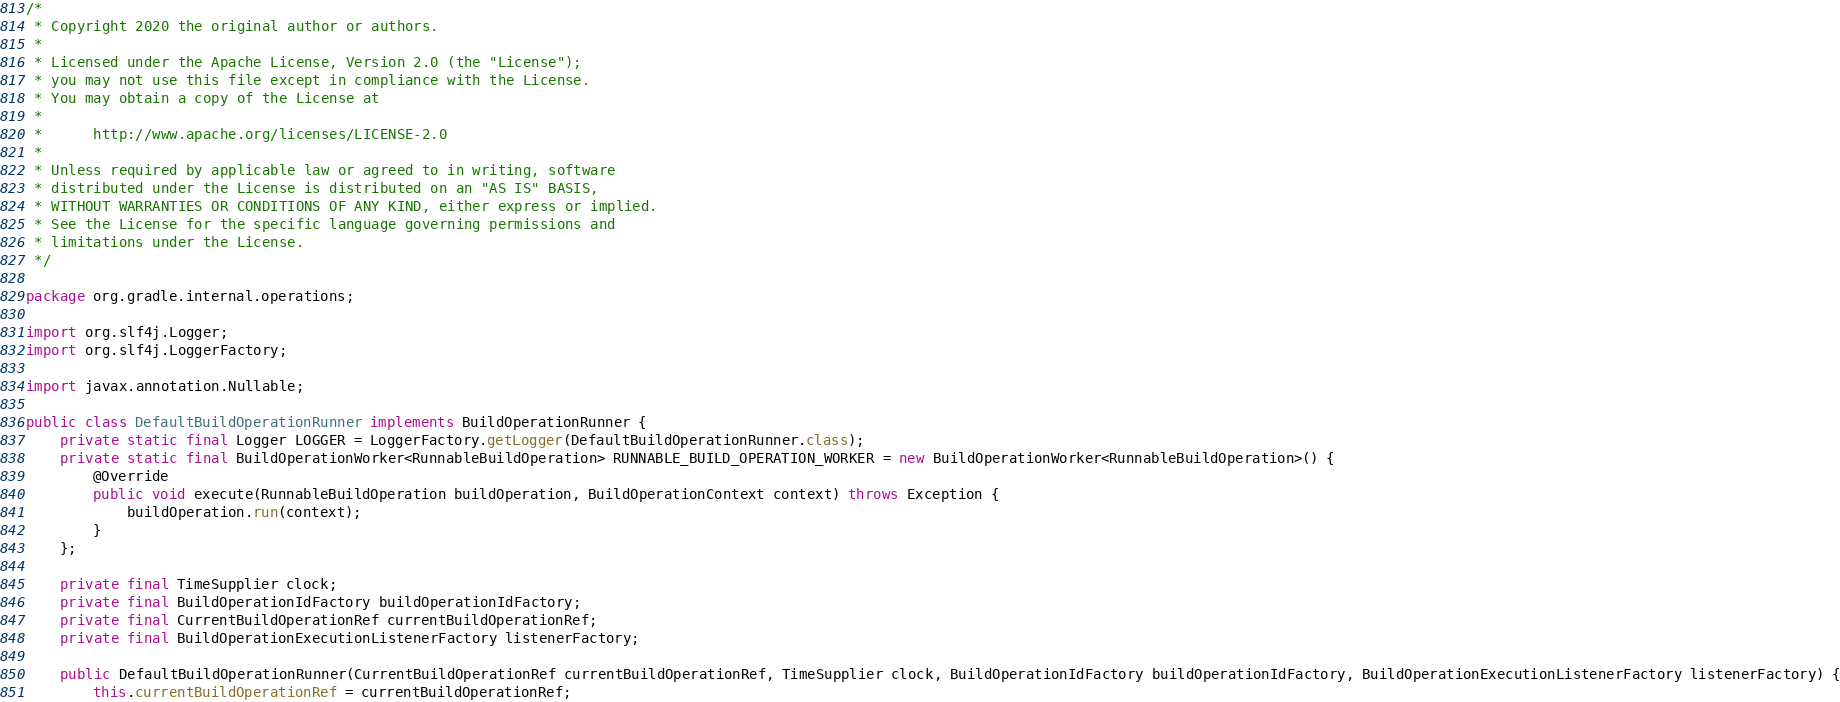Convert code to text. <code><loc_0><loc_0><loc_500><loc_500><_Java_>/*
 * Copyright 2020 the original author or authors.
 *
 * Licensed under the Apache License, Version 2.0 (the "License");
 * you may not use this file except in compliance with the License.
 * You may obtain a copy of the License at
 *
 *      http://www.apache.org/licenses/LICENSE-2.0
 *
 * Unless required by applicable law or agreed to in writing, software
 * distributed under the License is distributed on an "AS IS" BASIS,
 * WITHOUT WARRANTIES OR CONDITIONS OF ANY KIND, either express or implied.
 * See the License for the specific language governing permissions and
 * limitations under the License.
 */

package org.gradle.internal.operations;

import org.slf4j.Logger;
import org.slf4j.LoggerFactory;

import javax.annotation.Nullable;

public class DefaultBuildOperationRunner implements BuildOperationRunner {
    private static final Logger LOGGER = LoggerFactory.getLogger(DefaultBuildOperationRunner.class);
    private static final BuildOperationWorker<RunnableBuildOperation> RUNNABLE_BUILD_OPERATION_WORKER = new BuildOperationWorker<RunnableBuildOperation>() {
        @Override
        public void execute(RunnableBuildOperation buildOperation, BuildOperationContext context) throws Exception {
            buildOperation.run(context);
        }
    };

    private final TimeSupplier clock;
    private final BuildOperationIdFactory buildOperationIdFactory;
    private final CurrentBuildOperationRef currentBuildOperationRef;
    private final BuildOperationExecutionListenerFactory listenerFactory;

    public DefaultBuildOperationRunner(CurrentBuildOperationRef currentBuildOperationRef, TimeSupplier clock, BuildOperationIdFactory buildOperationIdFactory, BuildOperationExecutionListenerFactory listenerFactory) {
        this.currentBuildOperationRef = currentBuildOperationRef;</code> 